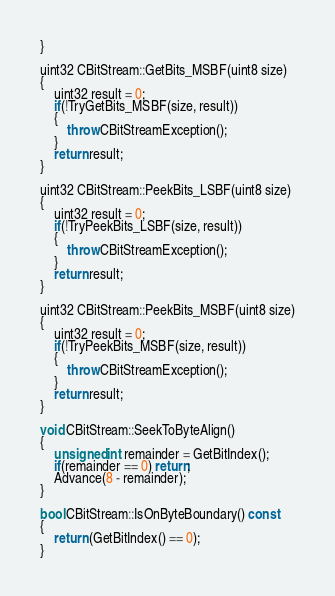<code> <loc_0><loc_0><loc_500><loc_500><_C++_>}

uint32 CBitStream::GetBits_MSBF(uint8 size)
{
	uint32 result = 0;
	if(!TryGetBits_MSBF(size, result))
	{
		throw CBitStreamException();
	}
	return result;
}

uint32 CBitStream::PeekBits_LSBF(uint8 size)
{
	uint32 result = 0;
	if(!TryPeekBits_LSBF(size, result))
	{
		throw CBitStreamException();
	}
	return result;
}

uint32 CBitStream::PeekBits_MSBF(uint8 size)
{
	uint32 result = 0;
	if(!TryPeekBits_MSBF(size, result))
	{
		throw CBitStreamException();
	}
	return result;
}

void CBitStream::SeekToByteAlign()
{
	unsigned int remainder = GetBitIndex();
	if(remainder == 0) return;
	Advance(8 - remainder);
}

bool CBitStream::IsOnByteBoundary() const
{
	return (GetBitIndex() == 0);
}</code> 